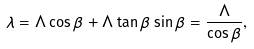<formula> <loc_0><loc_0><loc_500><loc_500>\lambda = \Lambda \cos { \beta } + \Lambda \tan { \beta } \sin { \beta } = \frac { \Lambda } { \cos { \beta } } ,</formula> 